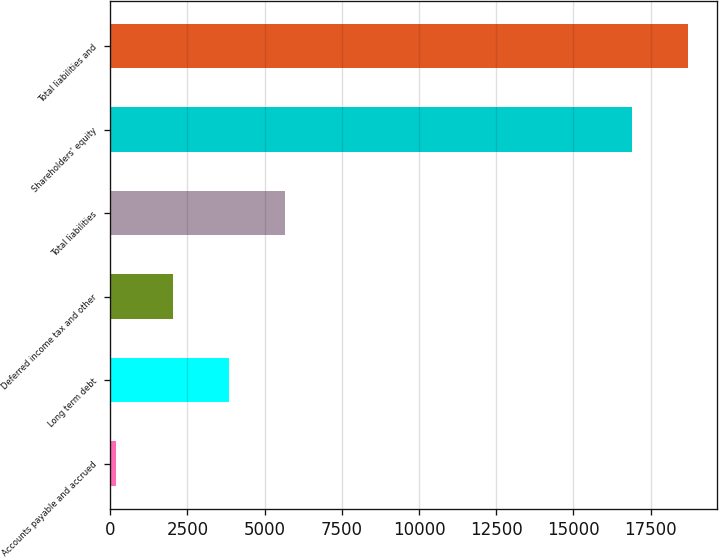Convert chart to OTSL. <chart><loc_0><loc_0><loc_500><loc_500><bar_chart><fcel>Accounts payable and accrued<fcel>Long term debt<fcel>Deferred income tax and other<fcel>Total liabilities<fcel>Shareholders' equity<fcel>Total liabilities and<nl><fcel>202<fcel>3849.4<fcel>2025.7<fcel>5673.1<fcel>16899<fcel>18722.7<nl></chart> 